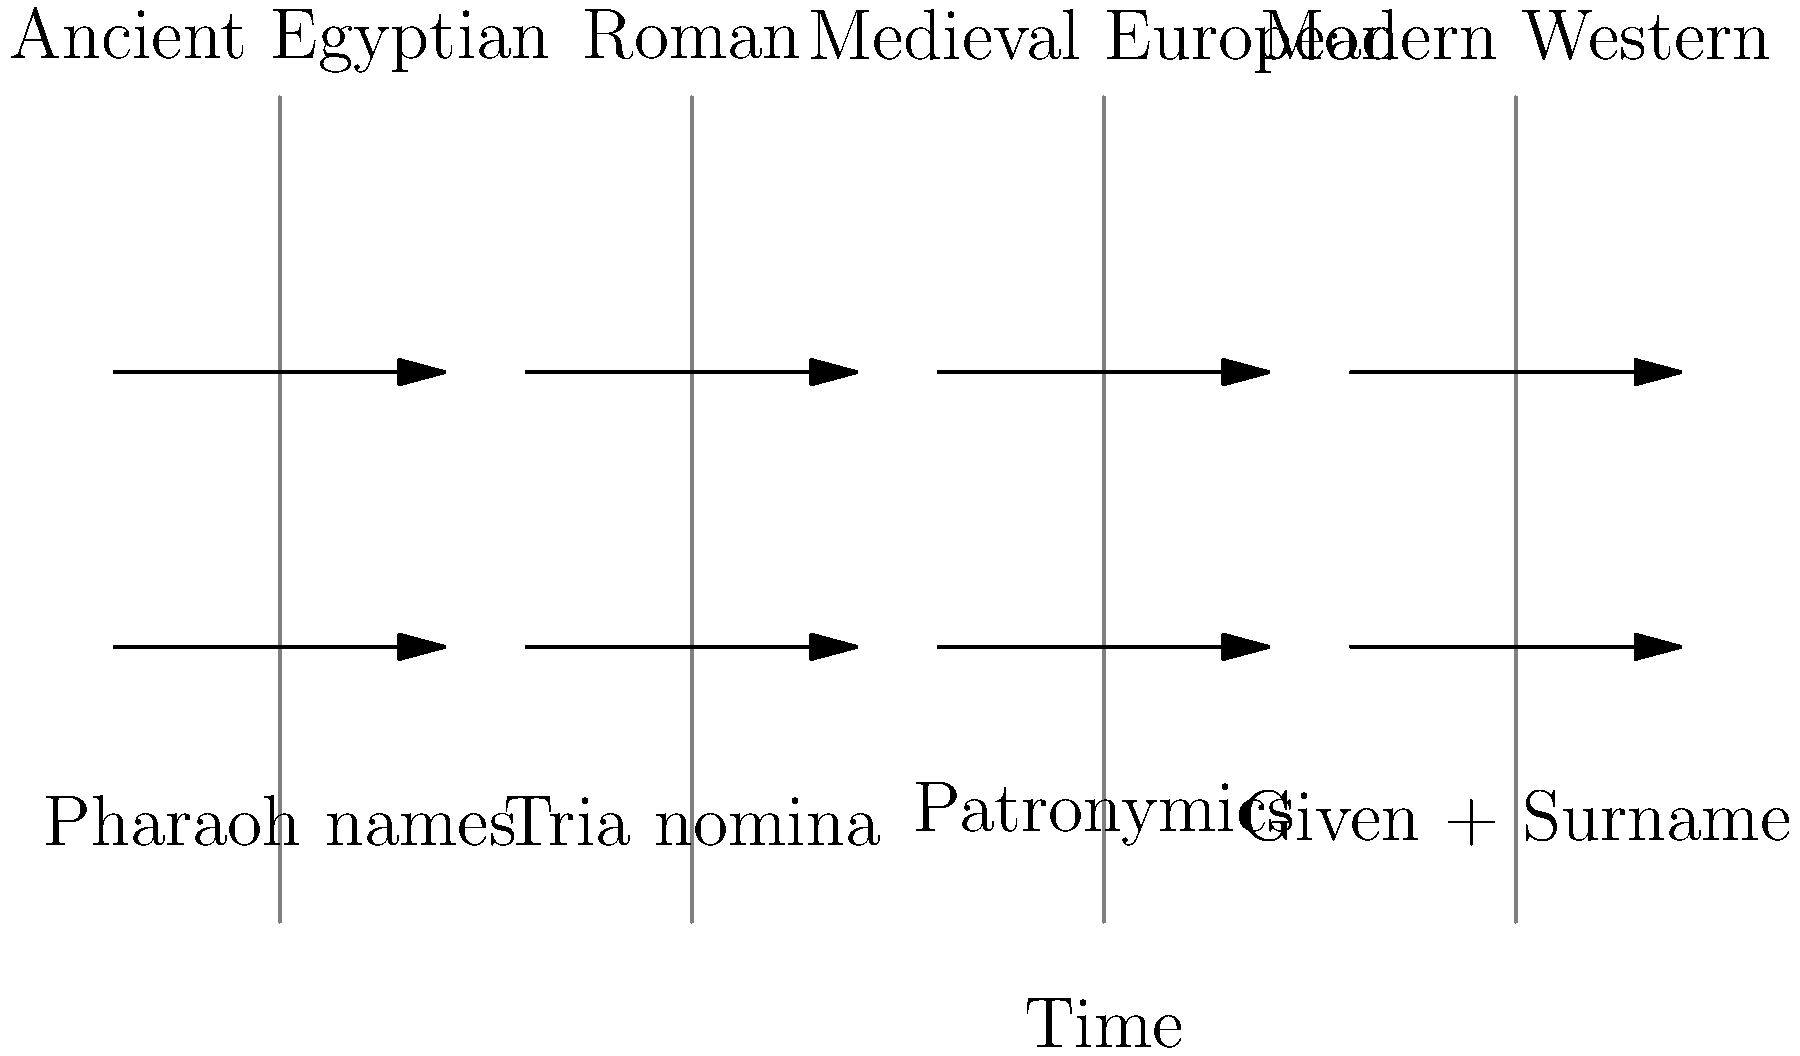Based on the timeline of naming conventions shown, which cultural period introduced the concept of patronymics, and how did this system differ from its predecessor? To answer this question, let's analyze the evolution of naming conventions as depicted in the graphic:

1. Ancient Egyptian: The earliest system shown, characterized by Pharaoh names. These were often complex, incorporating divine elements and titles.

2. Roman: Introduced the tria nomina system, consisting of praenomen (given name), nomen (clan name), and cognomen (family name or nickname).

3. Medieval European: This period introduced patronymics, which is the system we're asked about. Patronymics are names derived from the father's name.

4. Modern Western: The current system of given name plus surname.

The patronymic system (Medieval European) differed from its predecessor (Roman tria nomina) in several ways:

a) It was typically based on the father's name, e.g., "Johnson" meaning "son of John."
b) It was more flexible and could change with each generation.
c) It didn't necessarily indicate a fixed family lineage like the Roman nomen did.
d) It was simpler, usually consisting of two elements (given name + patronymic) instead of three.
Answer: Medieval European; names derived from father's name, changing each generation 